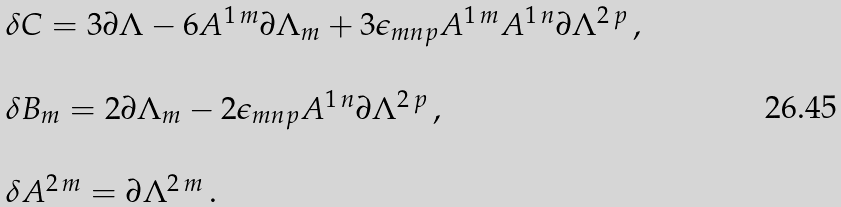<formula> <loc_0><loc_0><loc_500><loc_500>\begin{array} { r c l } & & \delta C = 3 \partial \Lambda - 6 A ^ { 1 \, m } \partial \Lambda _ { m } + 3 \epsilon _ { m n p } A ^ { 1 \, m } A ^ { 1 \, n } \partial \Lambda ^ { 2 \, p } \, , \\ & & \\ & & \delta B _ { m } = 2 \partial \Lambda _ { m } - 2 \epsilon _ { m n p } A ^ { 1 \, n } \partial \Lambda ^ { 2 \, p } \, , \\ & & \\ & & \delta A ^ { 2 \, m } = \partial \Lambda ^ { 2 \, m } \, . \\ \end{array}</formula> 